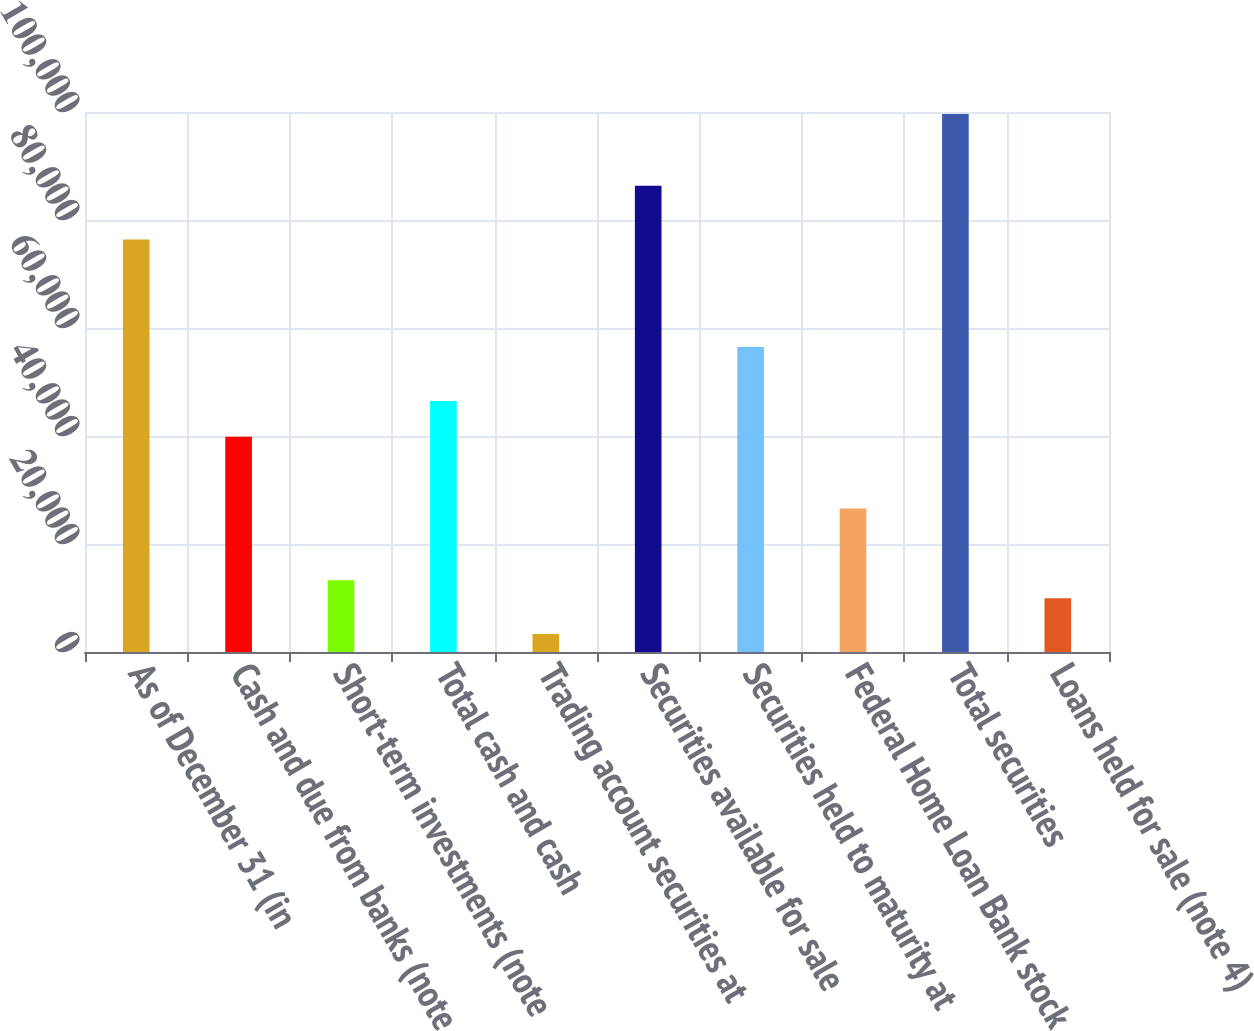Convert chart to OTSL. <chart><loc_0><loc_0><loc_500><loc_500><bar_chart><fcel>As of December 31 (in<fcel>Cash and due from banks (note<fcel>Short-term investments (note<fcel>Total cash and cash<fcel>Trading account securities at<fcel>Securities available for sale<fcel>Securities held to maturity at<fcel>Federal Home Loan Bank stock<fcel>Total securities<fcel>Loans held for sale (note 4)<nl><fcel>76386.4<fcel>39855.7<fcel>13287.8<fcel>46497.6<fcel>3324.88<fcel>86349.4<fcel>56460.6<fcel>26571.7<fcel>99633.3<fcel>9966.84<nl></chart> 